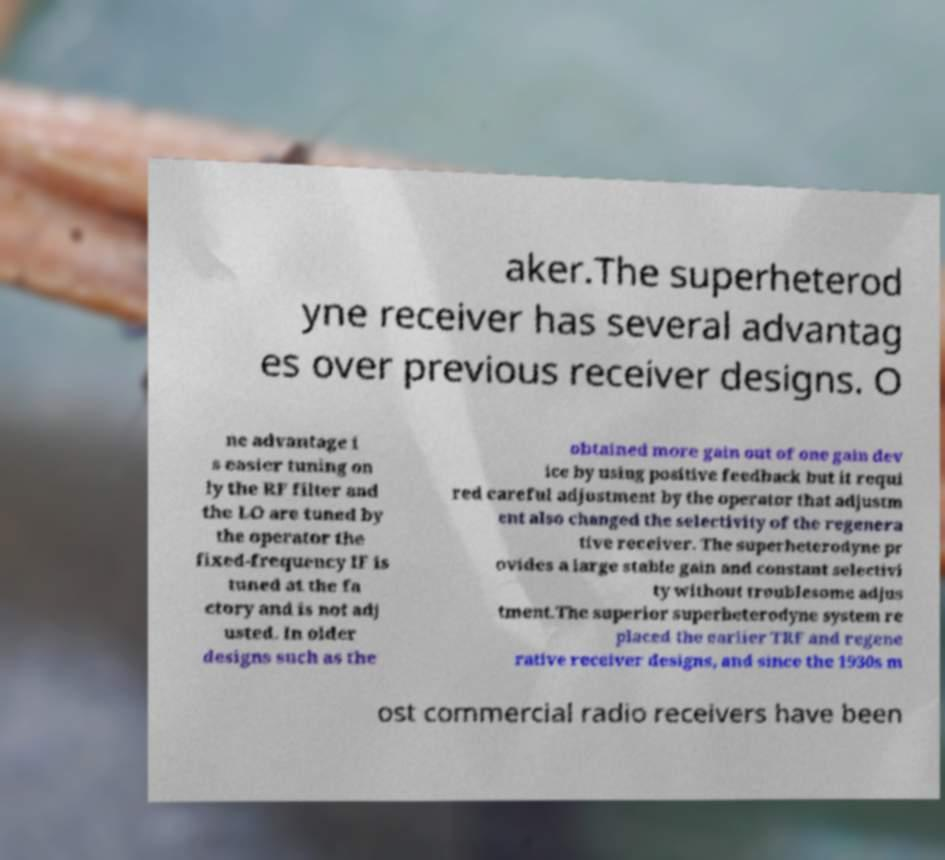Please read and relay the text visible in this image. What does it say? aker.The superheterod yne receiver has several advantag es over previous receiver designs. O ne advantage i s easier tuning on ly the RF filter and the LO are tuned by the operator the fixed-frequency IF is tuned at the fa ctory and is not adj usted. In older designs such as the obtained more gain out of one gain dev ice by using positive feedback but it requi red careful adjustment by the operator that adjustm ent also changed the selectivity of the regenera tive receiver. The superheterodyne pr ovides a large stable gain and constant selectivi ty without troublesome adjus tment.The superior superheterodyne system re placed the earlier TRF and regene rative receiver designs, and since the 1930s m ost commercial radio receivers have been 